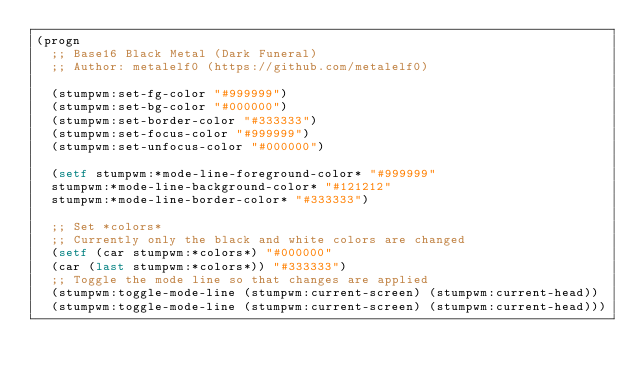<code> <loc_0><loc_0><loc_500><loc_500><_Lisp_>(progn
  ;; Base16 Black Metal (Dark Funeral)
  ;; Author: metalelf0 (https://github.com/metalelf0)

  (stumpwm:set-fg-color "#999999")
  (stumpwm:set-bg-color "#000000")
  (stumpwm:set-border-color "#333333")
  (stumpwm:set-focus-color "#999999")
  (stumpwm:set-unfocus-color "#000000")

  (setf stumpwm:*mode-line-foreground-color* "#999999"
	stumpwm:*mode-line-background-color* "#121212"
	stumpwm:*mode-line-border-color* "#333333")

  ;; Set *colors*
  ;; Currently only the black and white colors are changed
  (setf (car stumpwm:*colors*) "#000000"
	(car (last stumpwm:*colors*)) "#333333")
  ;; Toggle the mode line so that changes are applied
  (stumpwm:toggle-mode-line (stumpwm:current-screen) (stumpwm:current-head))
  (stumpwm:toggle-mode-line (stumpwm:current-screen) (stumpwm:current-head)))
       
</code> 